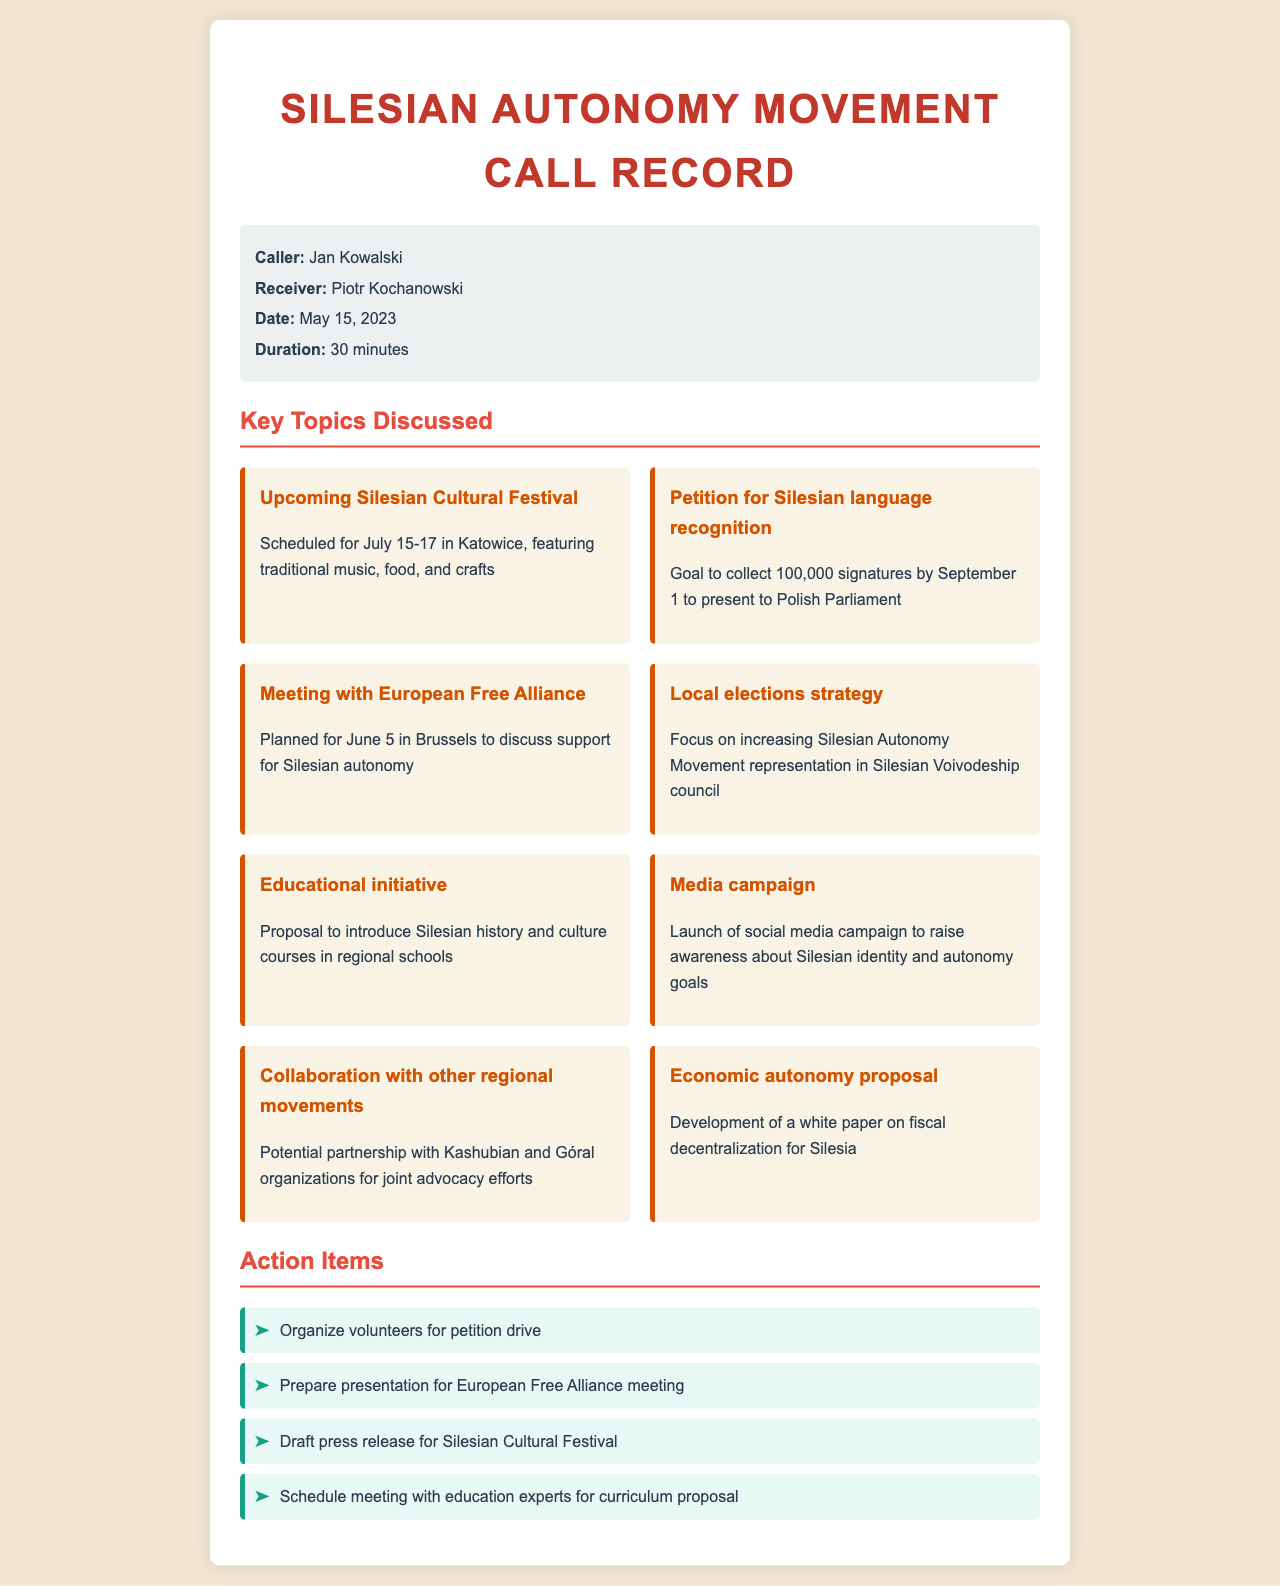What is the date of the call? The call took place on May 15, 2023.
Answer: May 15, 2023 Who was the caller? The caller is identified as Jan Kowalski.
Answer: Jan Kowalski What are the dates for the upcoming Silesian Cultural Festival? The festival is scheduled for July 15-17.
Answer: July 15-17 How many signatures are aimed to be collected for the Silesian language petition? The goal is to collect 100,000 signatures.
Answer: 100,000 What is the focus of the local elections strategy? The focus is on increasing representation in the Silesian Voivodeship council.
Answer: Increasing representation What meeting is scheduled for June 5? A meeting with the European Free Alliance is planned.
Answer: Meeting with European Free Alliance What is one of the action items from the call? One action item is to organize volunteers for the petition drive.
Answer: Organize volunteers for petition drive What type of campaign will be launched? A social media campaign will be launched.
Answer: Social media campaign Which regional movements are potential collaborators? Potential partnerships include Kashubian and Góral organizations.
Answer: Kashubian and Góral organizations 